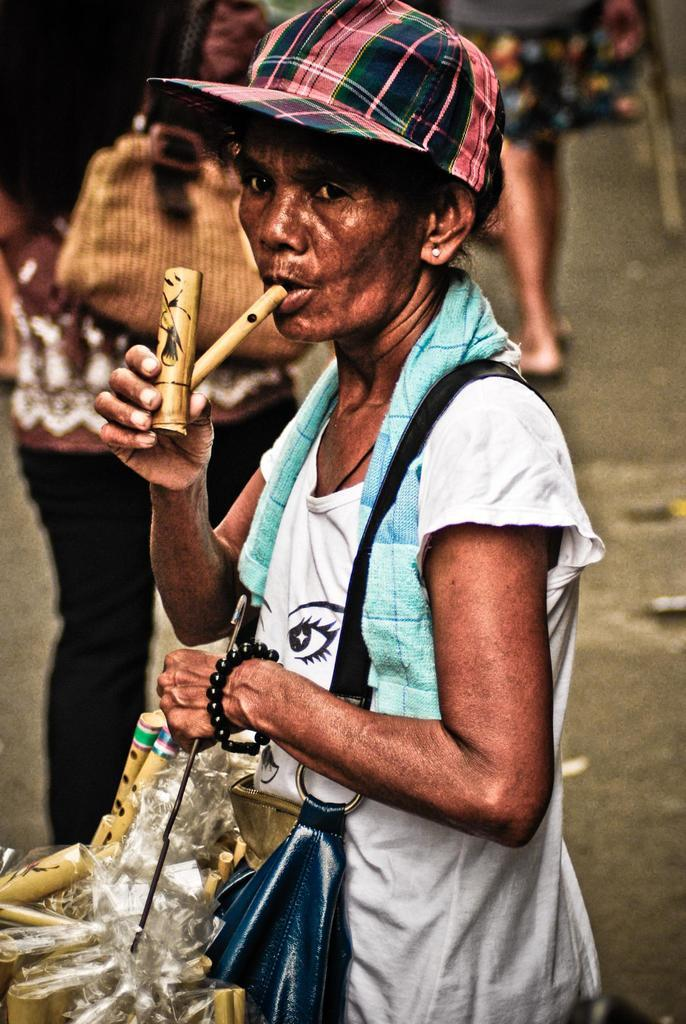What is the woman in the image doing? A: The woman is standing in the image and smoking a cigar. What is the woman holding in the image? The woman is holding some objects in the image. Can you describe the scene in the background of the image? There are other people visible in the background of the image. How many basketballs can be seen being played with by the pigs in the image? There are no basketballs or pigs present in the image. 